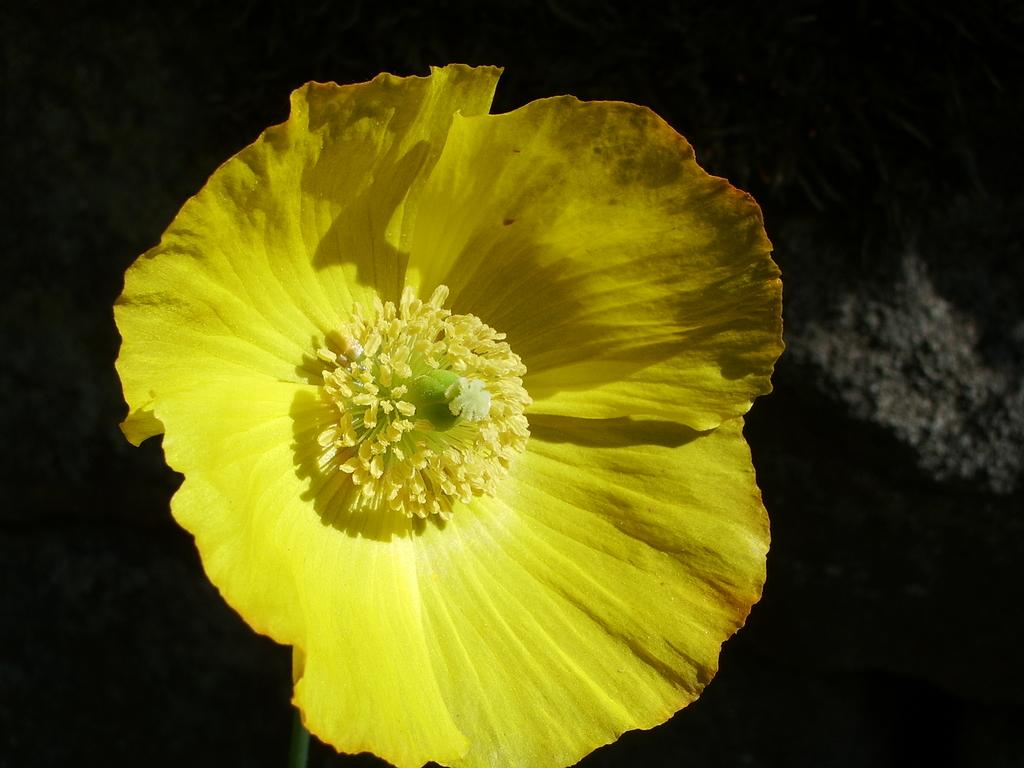What is the main subject in the foreground of the image? There is a flower in the foreground of the image. What color is the flower? The flower is yellow in color. What can be seen in the background of the image? There is a wall in the background of the image. Can you see the harmony between the flower and the wall in the image? The concept of harmony is not present in the image, as it only features a flower and a wall. 